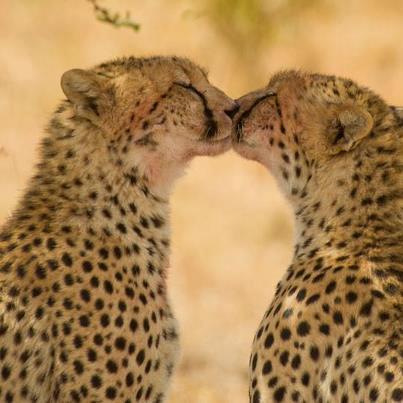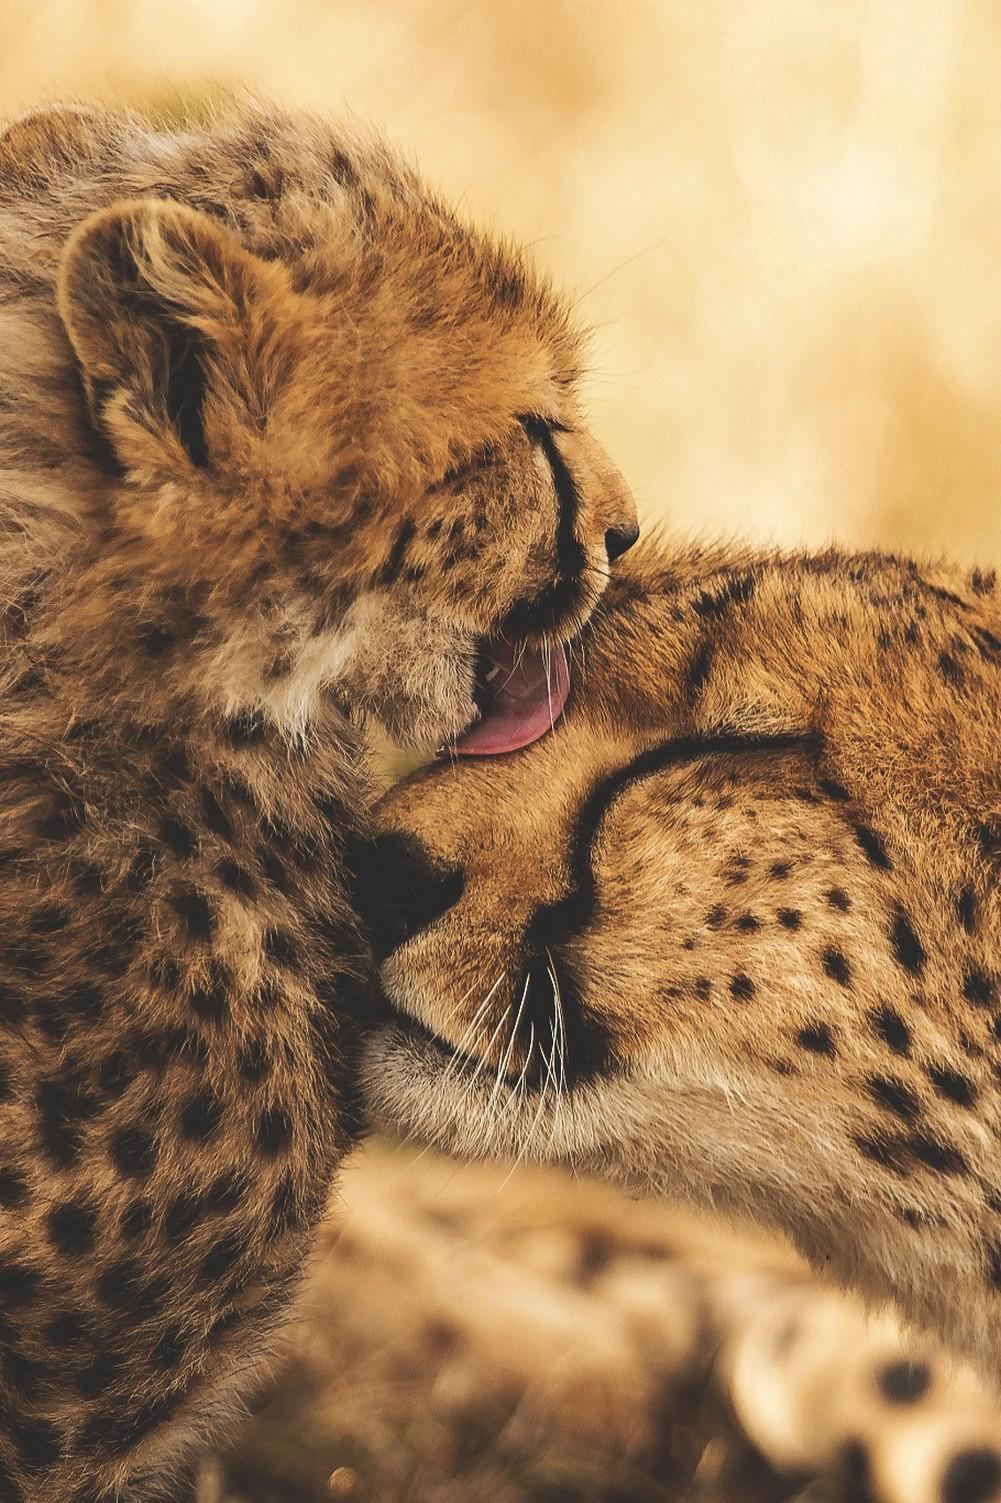The first image is the image on the left, the second image is the image on the right. Considering the images on both sides, is "The left image shows two spotted wildcats face to face, with heads level, and the right image shows exactly one spotted wildcat licking the other." valid? Answer yes or no. Yes. The first image is the image on the left, the second image is the image on the right. Evaluate the accuracy of this statement regarding the images: "At least one leopard's tongue is visible.". Is it true? Answer yes or no. Yes. 